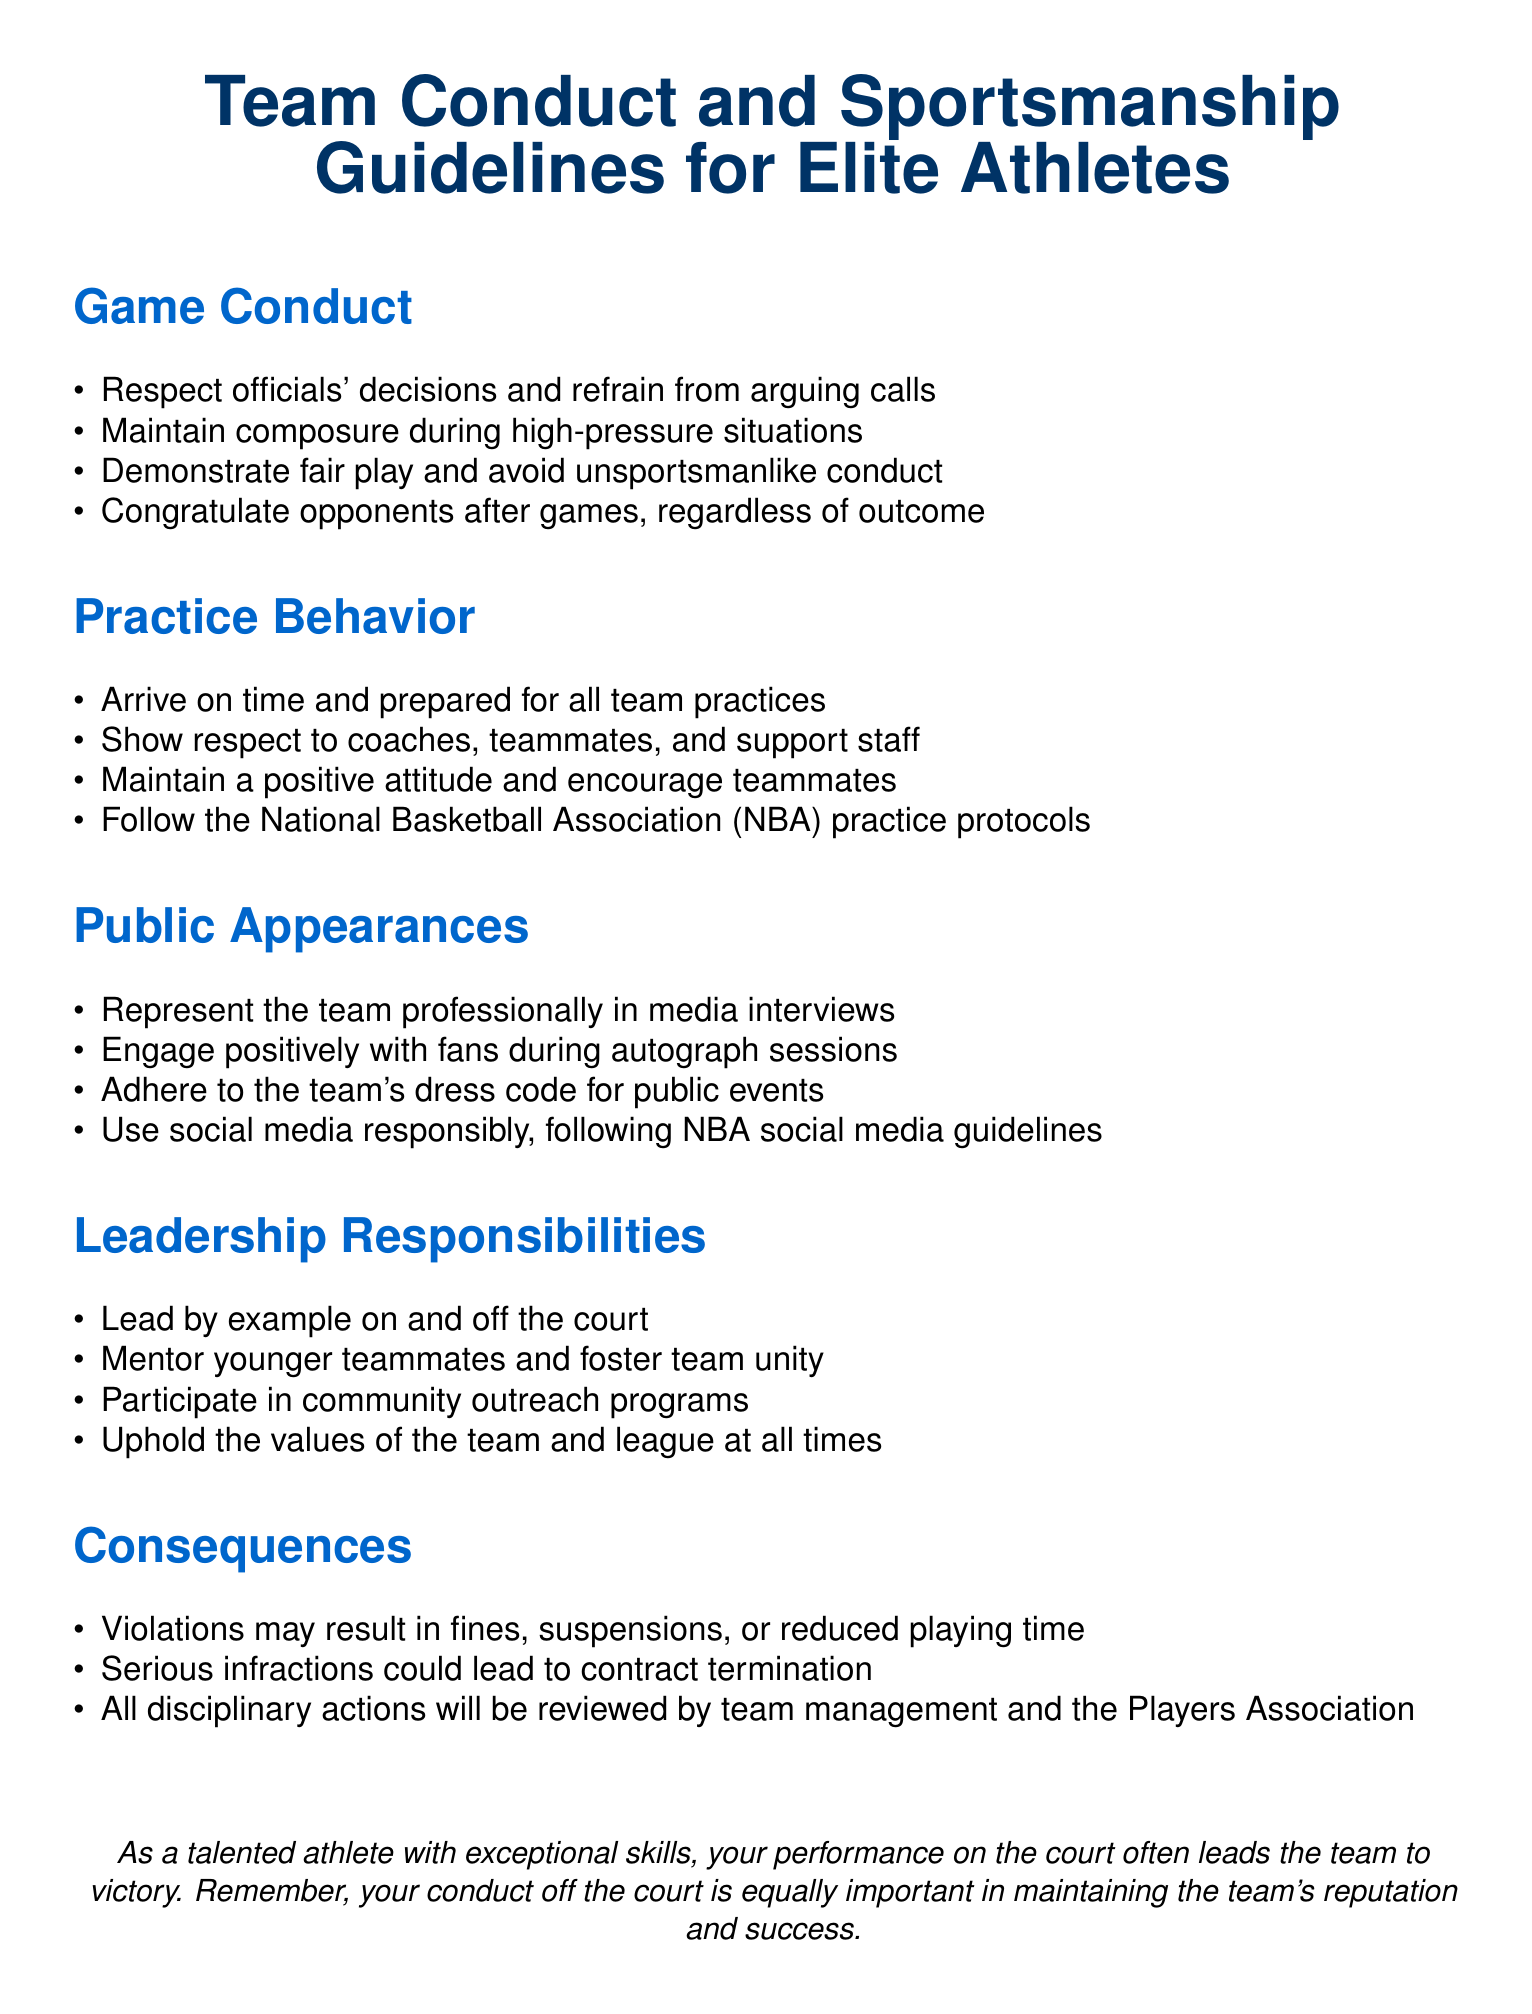What are the expected behaviors during games? The section on Game Conduct lists expected behaviors, including respecting officials, maintaining composure, demonstrating fair play, and congratulating opponents.
Answer: Respect officials, maintain composure, demonstrate fair play, congratulate opponents What should athletes do during practices? The Practice Behavior section outlines key behaviors, such as arriving on time, showing respect, maintaining a positive attitude, and following NBA protocols.
Answer: Arrive on time, show respect, maintain positive attitude, follow NBA protocols What is one responsibility of team leaders? Leadership Responsibilities highlights specific duties for leaders, one of which is to lead by example.
Answer: Lead by example What might happen if someone violates the guidelines? The Consequences section details potential outcomes for violations, including fines, suspensions, or reduced playing time.
Answer: Fines, suspensions, reduced playing time What is the team's stance on social media use? The Public Appearances section emphasizes the importance of using social media responsibly and following NBA guidelines.
Answer: Use social media responsibly What do athletes need to consider during public appearances? The document outlines expectations for how to represent the team in public, including engaging with fans and adhering to dress codes.
Answer: Represent team professionally, engage positively, adhere to dress code 